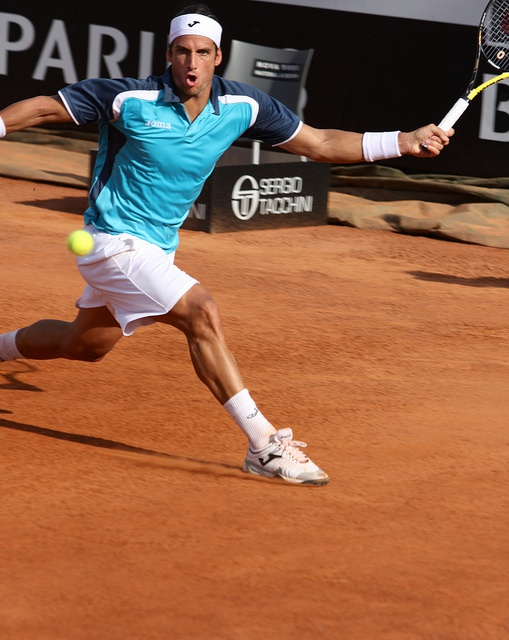Describe the objects in this image and their specific colors. I can see people in black, lavender, maroon, and brown tones, tennis racket in black, gray, white, and darkgray tones, and sports ball in black, khaki, tan, and olive tones in this image. 